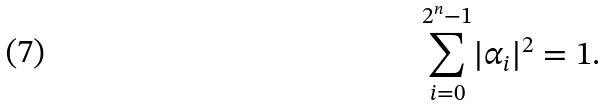Convert formula to latex. <formula><loc_0><loc_0><loc_500><loc_500>\underset { i = 0 } { \overset { 2 ^ { n } - 1 } { \sum } } | \alpha _ { i } | ^ { 2 } = 1 .</formula> 